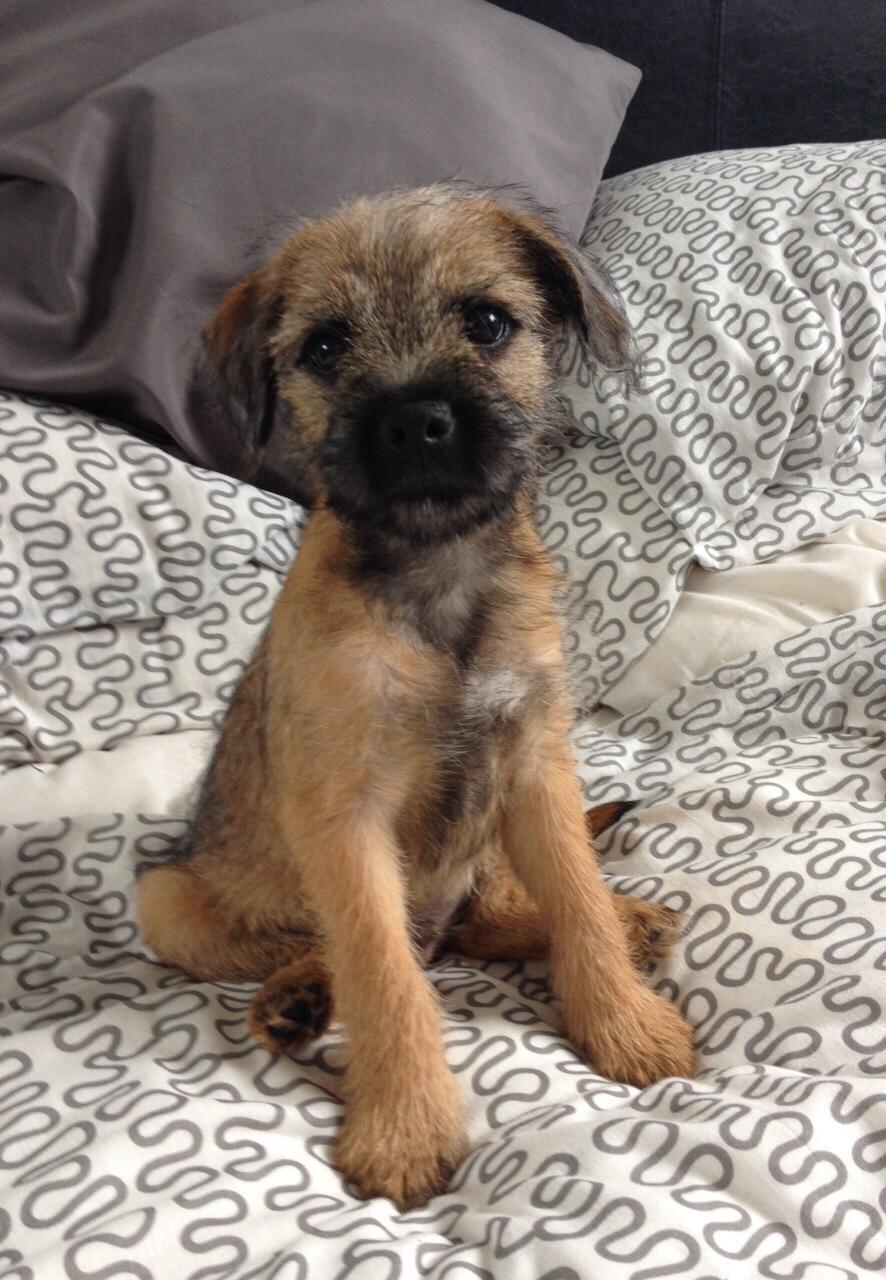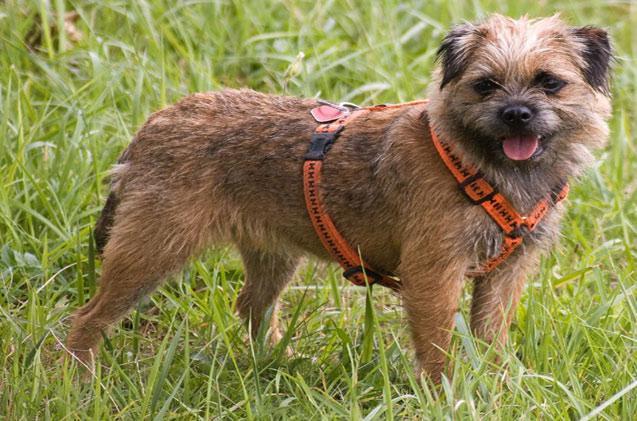The first image is the image on the left, the second image is the image on the right. For the images shown, is this caption "A dog posed outdoors is wearing something that buckles and extends around its neck." true? Answer yes or no. Yes. 